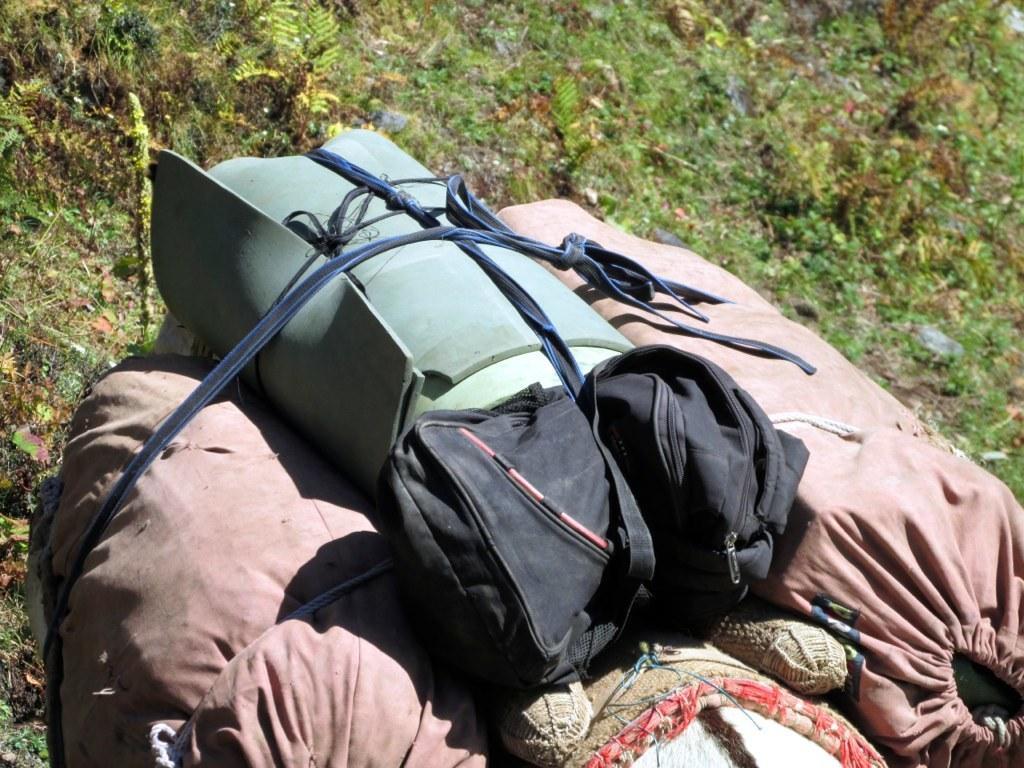Please provide a concise description of this image. In this picture we can see bags and this is grass. 